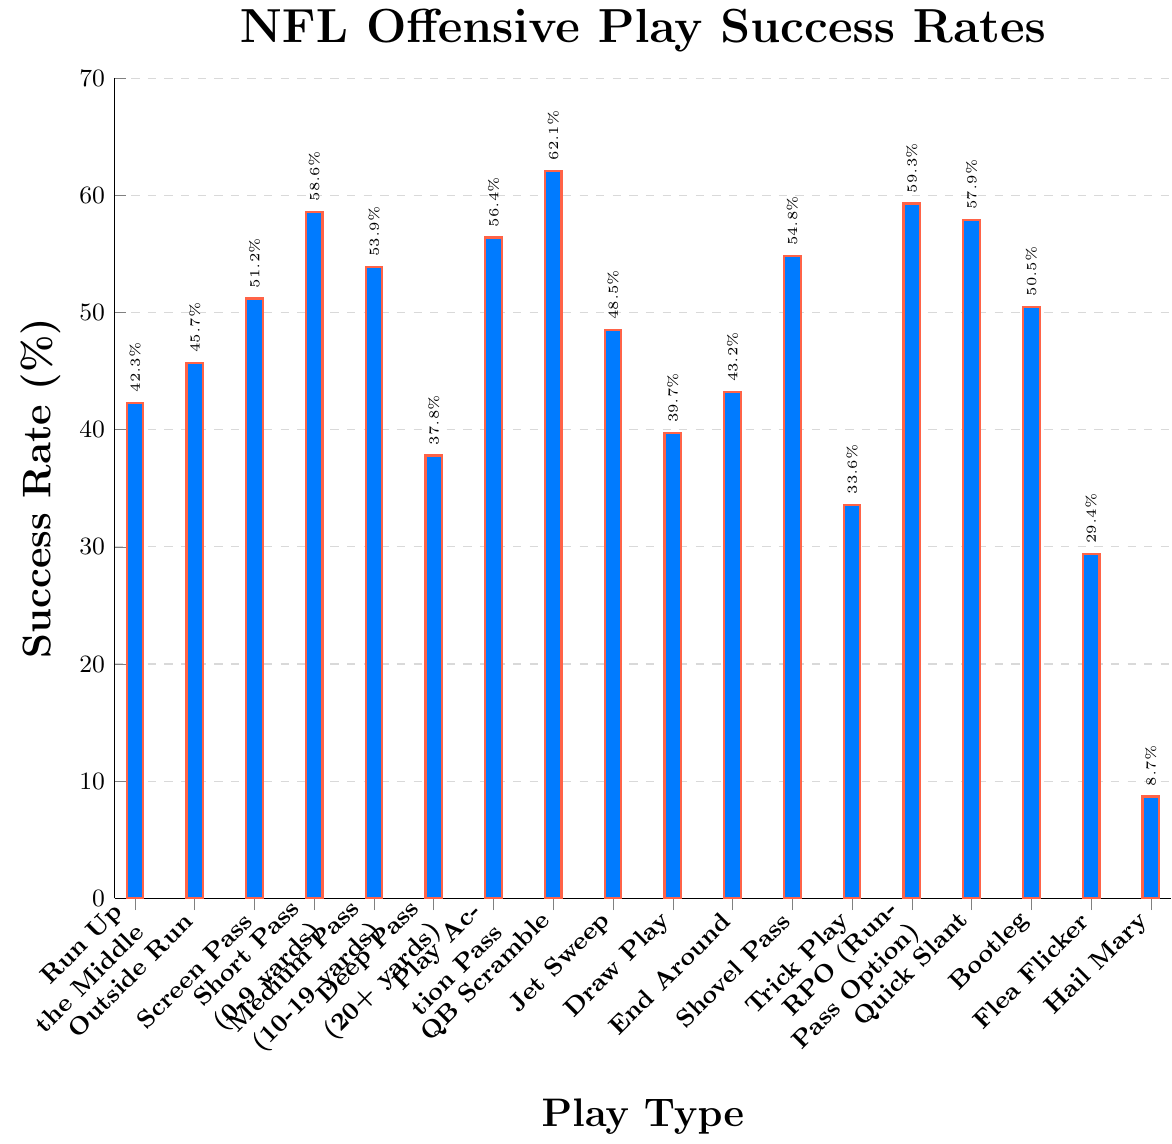Which play type has the highest success rate? To find the play type with the highest success rate, look at the top of the y-axis and find the bar that reaches the highest point. For this chart, the QB Scramble has the highest success rate at 62.1%.
Answer: QB Scramble What is the difference in success rate between a Screen Pass and a Trick Play? First, find the success rates for Screen Pass (51.2%) and Trick Play (33.6%). Then subtract the smaller rate from the larger rate: 51.2% - 33.6% = 17.6%.
Answer: 17.6% Which play types have success rates greater than 50%? Identify the bars that go beyond the 50% mark on the y-axis. These are Quick Slant, RPO (Run-Pass Option), Play Action Pass, Shovel Pass, Medium Pass (10-19 yards), Short Pass (0-9 yards), and Screen Pass.
Answer: Quick Slant, RPO (Run-Pass Option), Play Action Pass, Shovel Pass, Medium Pass (10-19 yards), Short Pass (0-9 yards), Screen Pass What is the average success rate of a Hail Mary and a Flea Flicker? Look at the success rates for Hail Mary (8.7%) and Flea Flicker (29.4%). Add these two percentages and divide by 2: (8.7% + 29.4%) / 2 = 19.05%.
Answer: 19.05% Which play type has a higher success rate: Draw Play or Outside Run? Compare the success rates of Draw Play (39.7%) and Outside Run (45.7%). Outside Run is higher.
Answer: Outside Run What is the total success rate if you combine Run Up the Middle, End Around, and Bootleg? Add the success rates of each play: Run Up the Middle (42.3%), End Around (43.2%), and Bootleg (50.5%). The total is 42.3% + 43.2% + 50.5% = 136%.
Answer: 136% Is the success rate of a Deep Pass greater than or less than Screen Pass? Compare the success rates of Deep Pass (37.8%) and Screen Pass (51.2%). Deep Pass is less than Screen Pass.
Answer: Less What is the median success rate of all the given play types? List the success rates in ascending order: 8.7%, 29.4%, 33.6%, 37.8%, 39.7%, 42.3%, 43.2%, 45.7%, 48.5%, 50.5%, 51.2%, 53.9%, 54.8%, 56.4%, 57.9%, 58.6%, 59.3%, 62.1%. The middle value (median) is 50.5%.
Answer: 50.5% Which play type is closer in success rate to 40%: Draw Play or End Around? Compare the distances from 40% to the success rates of Draw Play (39.7%) and End Around (43.2%). Draw Play is closer to 40% than End Around is.
Answer: Draw Play 